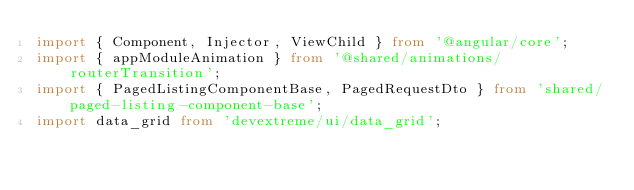<code> <loc_0><loc_0><loc_500><loc_500><_TypeScript_>import { Component, Injector, ViewChild } from '@angular/core';
import { appModuleAnimation } from '@shared/animations/routerTransition';
import { PagedListingComponentBase, PagedRequestDto } from 'shared/paged-listing-component-base';
import data_grid from 'devextreme/ui/data_grid';</code> 